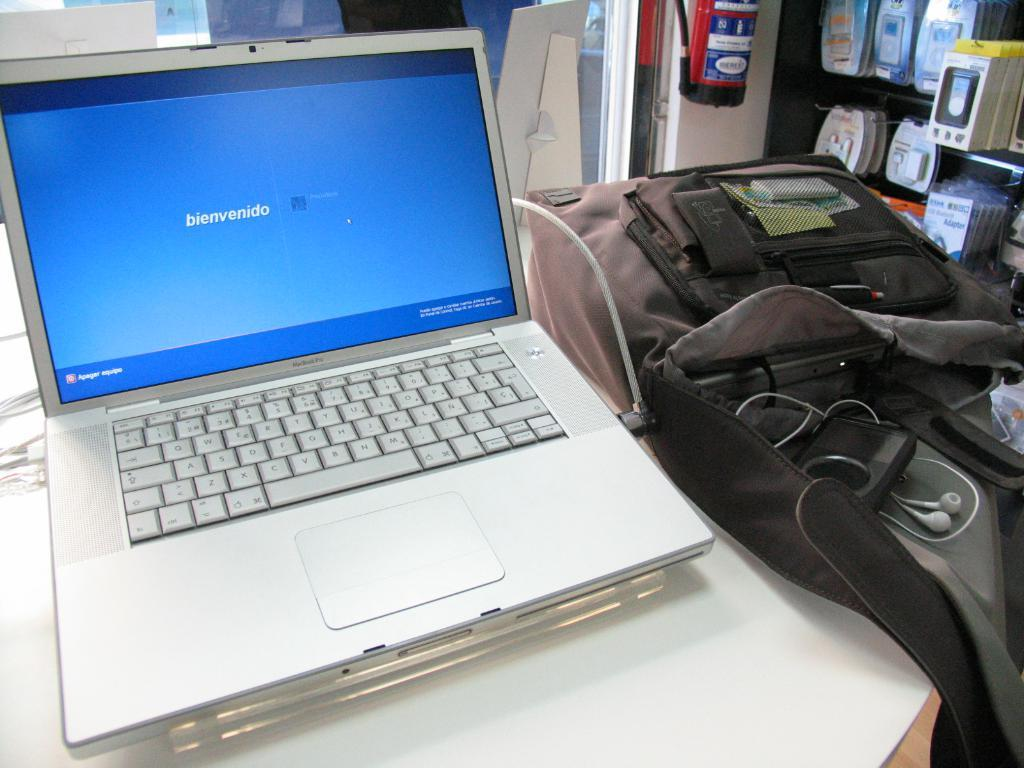What electronic device is visible in the image? There is a laptop in the image. What might be used for carrying items in the image? There is a bag in the image. What type of audio accessory is present in the image? There are earphones in the image. Can you describe any other objects in the image? There are some other unspecified objects in the image. What type of cream is being used to decorate the laptop in the image? There is no cream present in the image, and the laptop is not being decorated. 